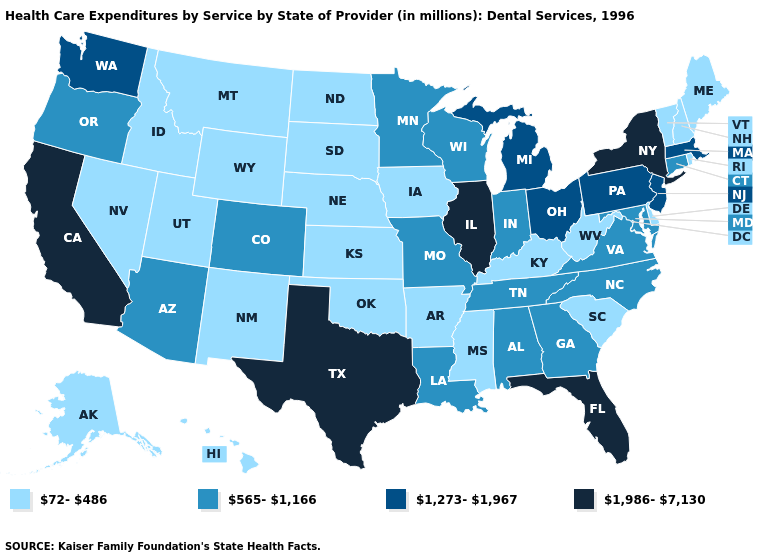What is the value of Maine?
Short answer required. 72-486. Does New Hampshire have the same value as Michigan?
Keep it brief. No. Which states have the highest value in the USA?
Concise answer only. California, Florida, Illinois, New York, Texas. Name the states that have a value in the range 72-486?
Short answer required. Alaska, Arkansas, Delaware, Hawaii, Idaho, Iowa, Kansas, Kentucky, Maine, Mississippi, Montana, Nebraska, Nevada, New Hampshire, New Mexico, North Dakota, Oklahoma, Rhode Island, South Carolina, South Dakota, Utah, Vermont, West Virginia, Wyoming. Which states have the lowest value in the Northeast?
Keep it brief. Maine, New Hampshire, Rhode Island, Vermont. Is the legend a continuous bar?
Quick response, please. No. Name the states that have a value in the range 1,986-7,130?
Write a very short answer. California, Florida, Illinois, New York, Texas. Which states have the lowest value in the USA?
Be succinct. Alaska, Arkansas, Delaware, Hawaii, Idaho, Iowa, Kansas, Kentucky, Maine, Mississippi, Montana, Nebraska, Nevada, New Hampshire, New Mexico, North Dakota, Oklahoma, Rhode Island, South Carolina, South Dakota, Utah, Vermont, West Virginia, Wyoming. Which states have the highest value in the USA?
Write a very short answer. California, Florida, Illinois, New York, Texas. Does Washington have the lowest value in the West?
Write a very short answer. No. What is the value of Tennessee?
Be succinct. 565-1,166. What is the lowest value in states that border Iowa?
Quick response, please. 72-486. Among the states that border Rhode Island , does Connecticut have the highest value?
Keep it brief. No. What is the value of Maryland?
Write a very short answer. 565-1,166. Which states have the lowest value in the West?
Give a very brief answer. Alaska, Hawaii, Idaho, Montana, Nevada, New Mexico, Utah, Wyoming. 